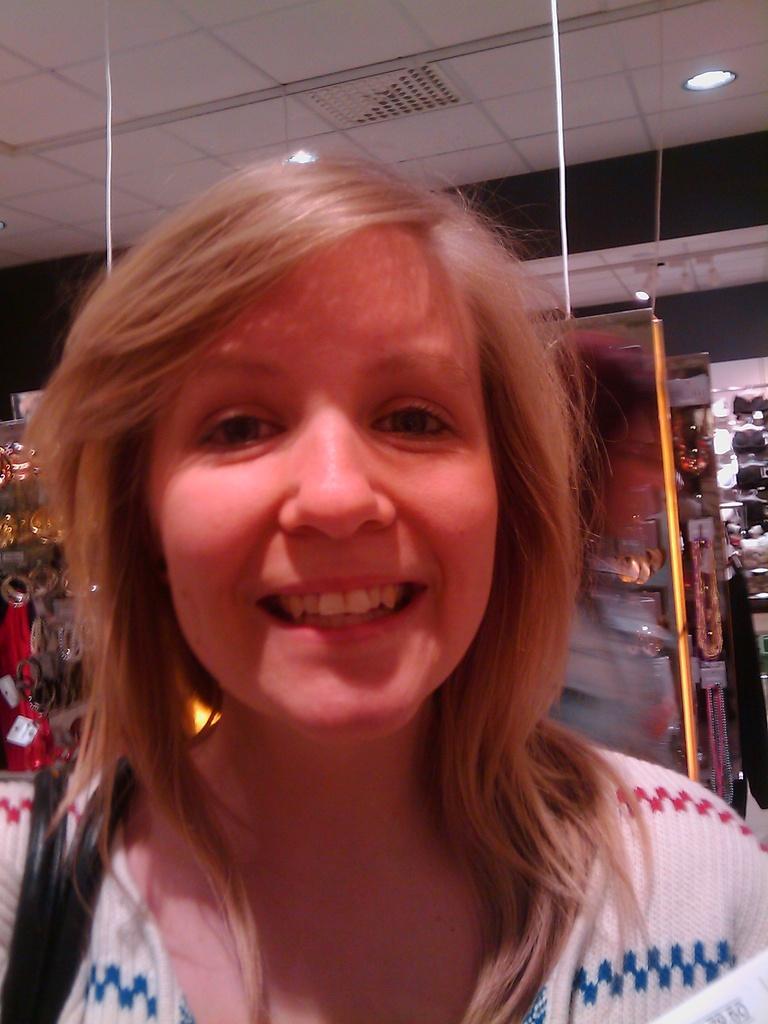Could you give a brief overview of what you see in this image? In this image there is a woman with a smile on her face, behind the women there are a few objects. 